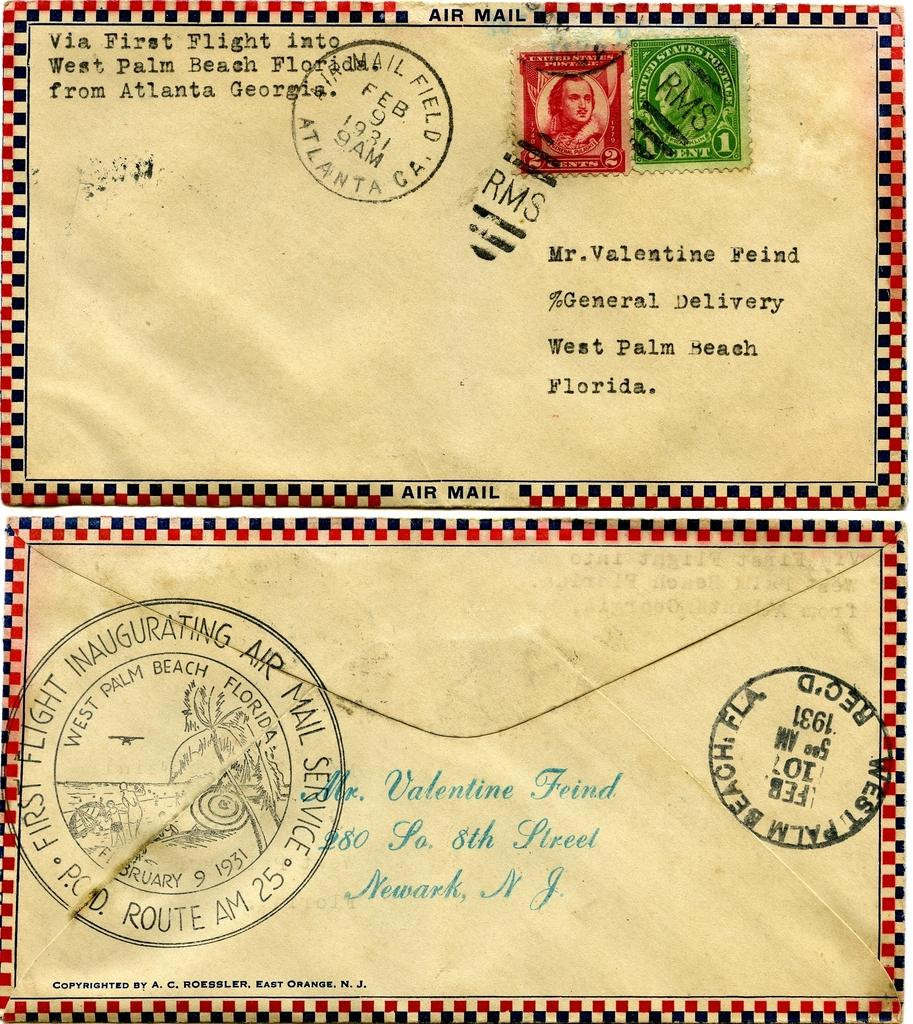<image>
Present a compact description of the photo's key features. a tan envelop with red and black squares around the border addressed to mr. valentine feind 